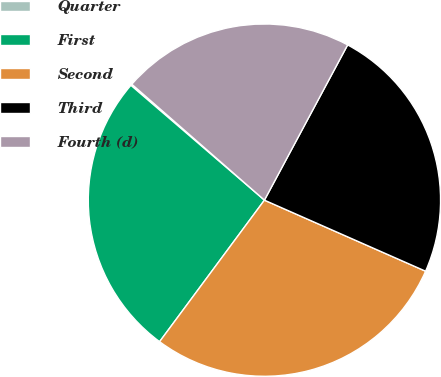Convert chart to OTSL. <chart><loc_0><loc_0><loc_500><loc_500><pie_chart><fcel>Quarter<fcel>First<fcel>Second<fcel>Third<fcel>Fourth (d)<nl><fcel>0.13%<fcel>26.16%<fcel>28.54%<fcel>23.78%<fcel>21.4%<nl></chart> 